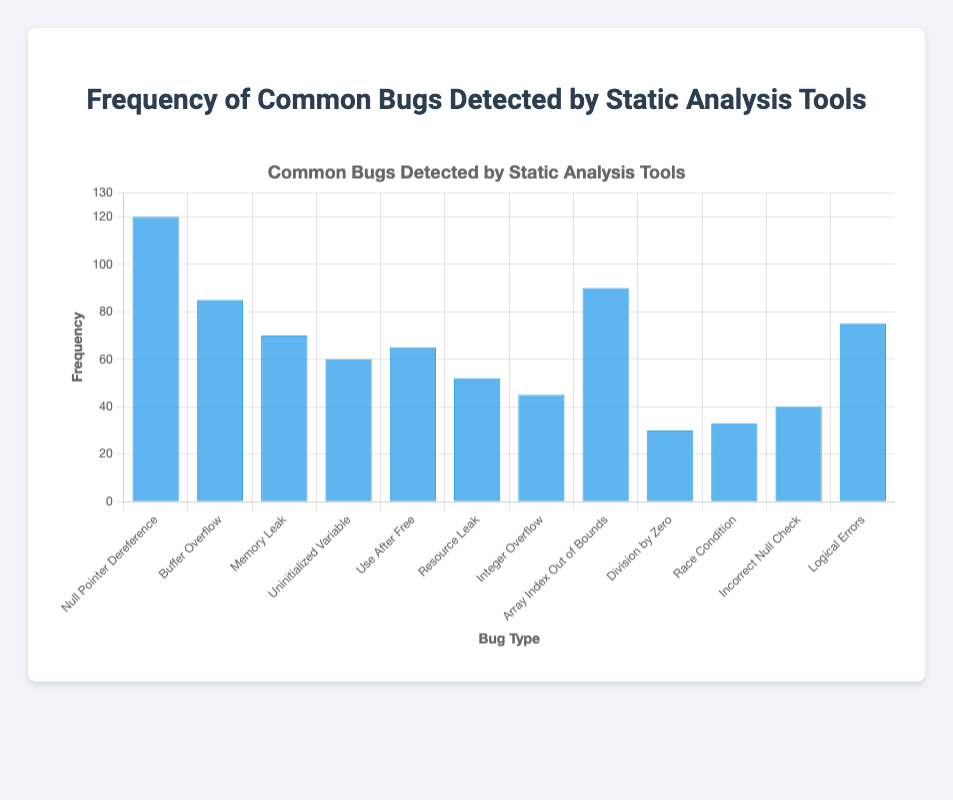What is the most common type of bug detected by static analysis tools? The most common type of bug can be identified by looking at the bar with the greatest height. In this case, it is the "Null Pointer Dereference" with a frequency of 120.
Answer: Null Pointer Dereference Which bug type has a lower frequency, Memory Leak or Use After Free? To determine this, compare the heights of the bars for "Memory Leak" and "Use After Free". The frequency for "Memory Leak" is 70, while "Use After Free" is 65.
Answer: Use After Free What is the difference in frequency between Buffer Overflow and Array Index Out of Bounds? Subtract the frequency of "Buffer Overflow" (85) from "Array Index Out of Bounds" (90). The difference is 90 - 85 = 5.
Answer: 5 Which bug has the lowest frequency? The lowest frequency can be found by identifying the shortest bar. The shortest bar corresponds to "Division by Zero" with a frequency of 30.
Answer: Division by Zero How many bug types have a frequency greater than 50? Count the number of bars with heights representing frequencies greater than 50. These are Null Pointer Dereference (120), Buffer Overflow (85), Memory Leak (70), Uninitialized Variable (60), Use After Free (65), Array Index Out of Bounds (90), and Logical Errors (75). There are 7 bars in total.
Answer: 7 What is the combined frequency of Division by Zero and Race Condition? Add the frequencies of "Division by Zero" (30) and "Race Condition" (33). The combined frequency is 30 + 33 = 63.
Answer: 63 Which bug type is more frequent: Resource Leak or Integer Overflow? Compare the heights of the bars for "Resource Leak" (52) and "Integer Overflow" (45). "Resource Leak" is more frequent.
Answer: Resource Leak What is the average frequency of all the bug types? Sum all the frequencies and divide by the number of bug types. The sum is 120 + 85 + 70 + 60 + 65 + 52 + 45 + 90 + 30 + 33 + 40 + 75 = 765. There are 12 bug types, so the average is 765 / 12 ≈ 63.75.
Answer: 63.75 What is the sum of frequencies for bug types with a frequency less than 50? Identify the bar heights for frequencies less than 50: Integer Overflow (45), Division by Zero (30), Race Condition (33), and Incorrect Null Check (40). Sum these frequencies: 45 + 30 + 33 + 40 = 148.
Answer: 148 Which has a higher frequency: the sum of Memory Leak and Logical Errors or the sum of Resource Leak and Array Index Out of Bounds? Calculate the sum of "Memory Leak" (70) and "Logical Errors" (75): 70 + 75 = 145. Calculate the sum of "Resource Leak" (52) and "Array Index Out of Bounds" (90): 52 + 90 = 142. 145 is higher than 142.
Answer: Memory Leak and Logical Errors 